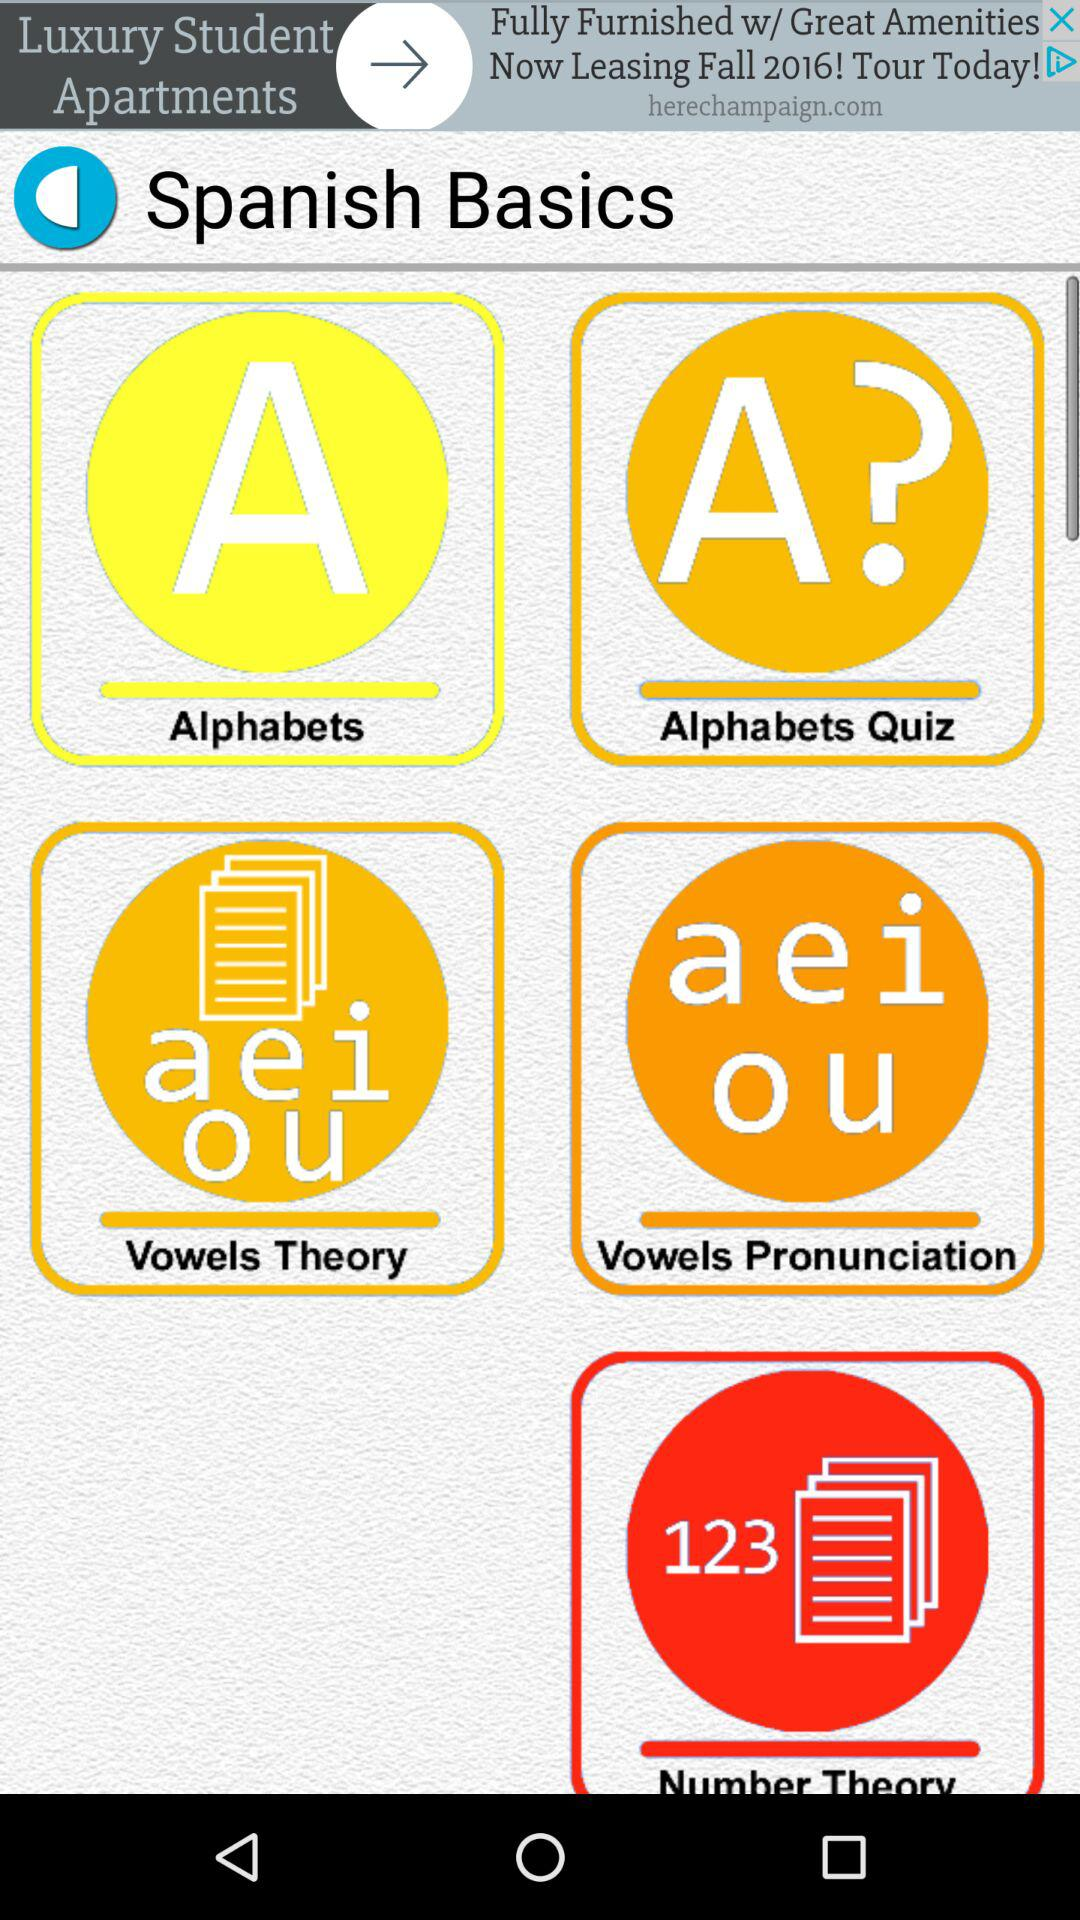What is the total number of number theories?
When the provided information is insufficient, respond with <no answer>. <no answer> 